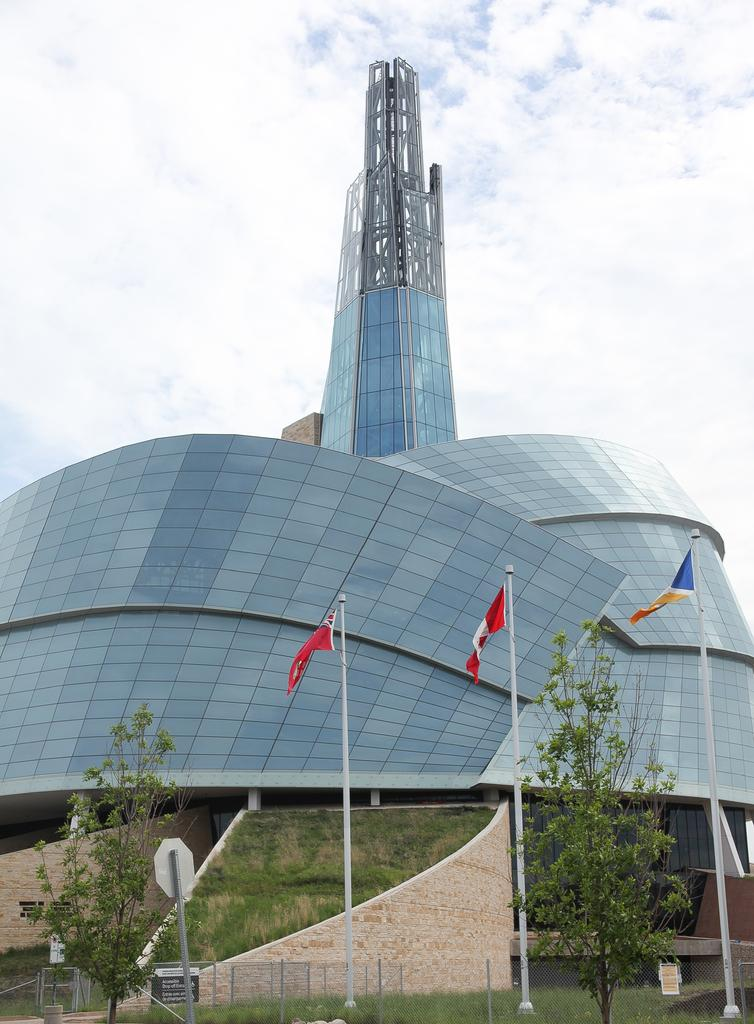What structures can be seen in the image? There are poles and a building visible in the image. What is attached to the poles in the image? Flags are attached to the poles in the image. What type of vegetation is present in the image? Trees and grass are present in the image. What is visible in the background of the image? The sky is visible in the background of the image. What is the condition of the sky in the image? The sky appears to be cloudy in the image. Is there any text or writing visible in the image? Yes, there is text or writing visible in the image. Where is the hammer being used in the image? There is no hammer present in the image. How old is the baby in the image? There is no baby present in the image. 